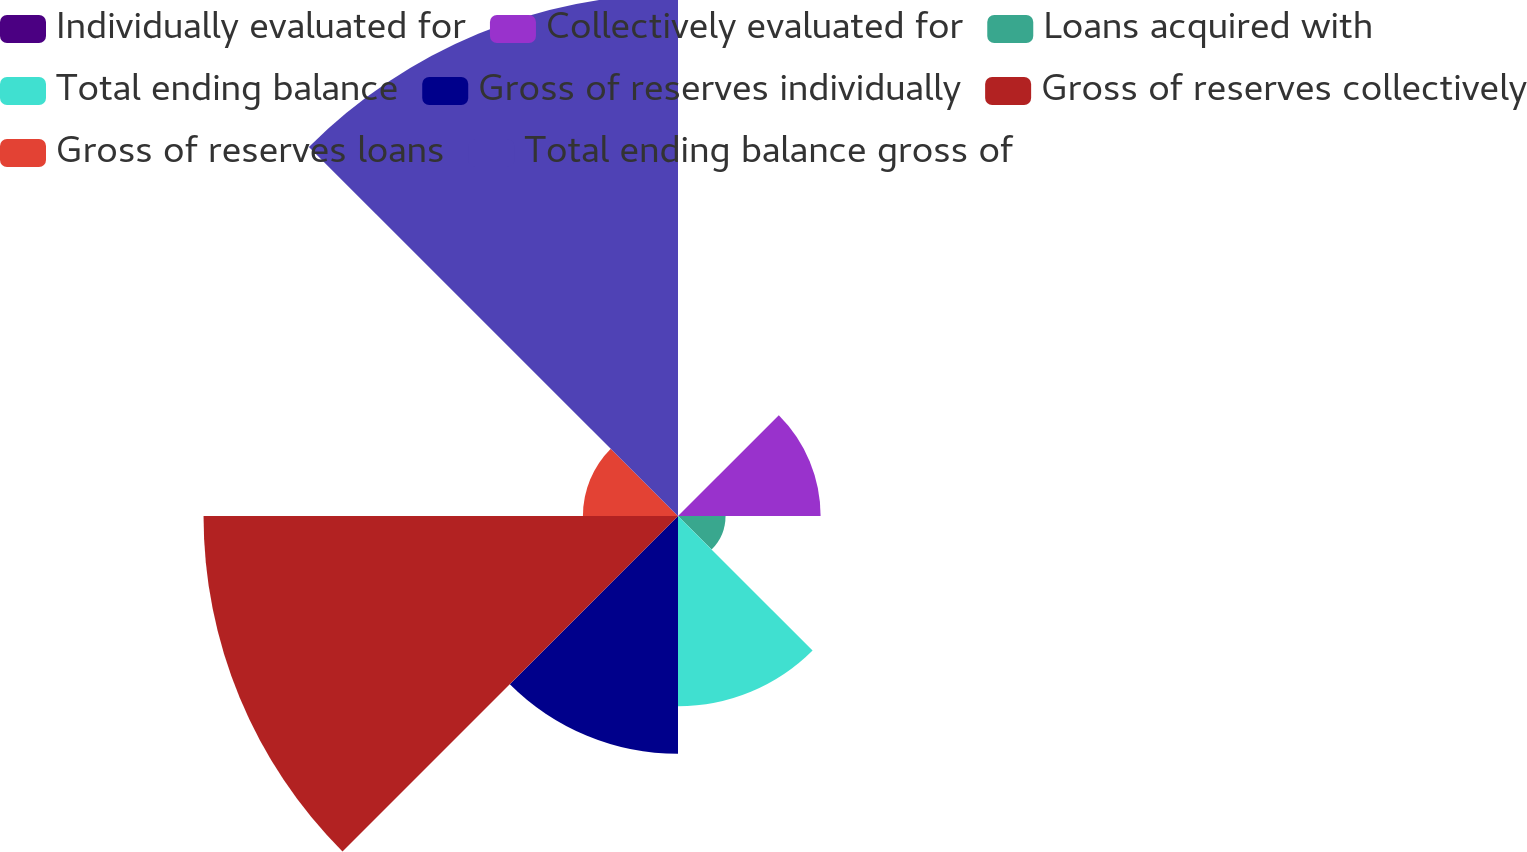Convert chart. <chart><loc_0><loc_0><loc_500><loc_500><pie_chart><fcel>Individually evaluated for<fcel>Collectively evaluated for<fcel>Loans acquired with<fcel>Total ending balance<fcel>Gross of reserves individually<fcel>Gross of reserves collectively<fcel>Gross of reserves loans<fcel>Total ending balance gross of<nl><fcel>0.0%<fcel>8.34%<fcel>2.78%<fcel>11.13%<fcel>13.91%<fcel>27.75%<fcel>5.56%<fcel>30.53%<nl></chart> 